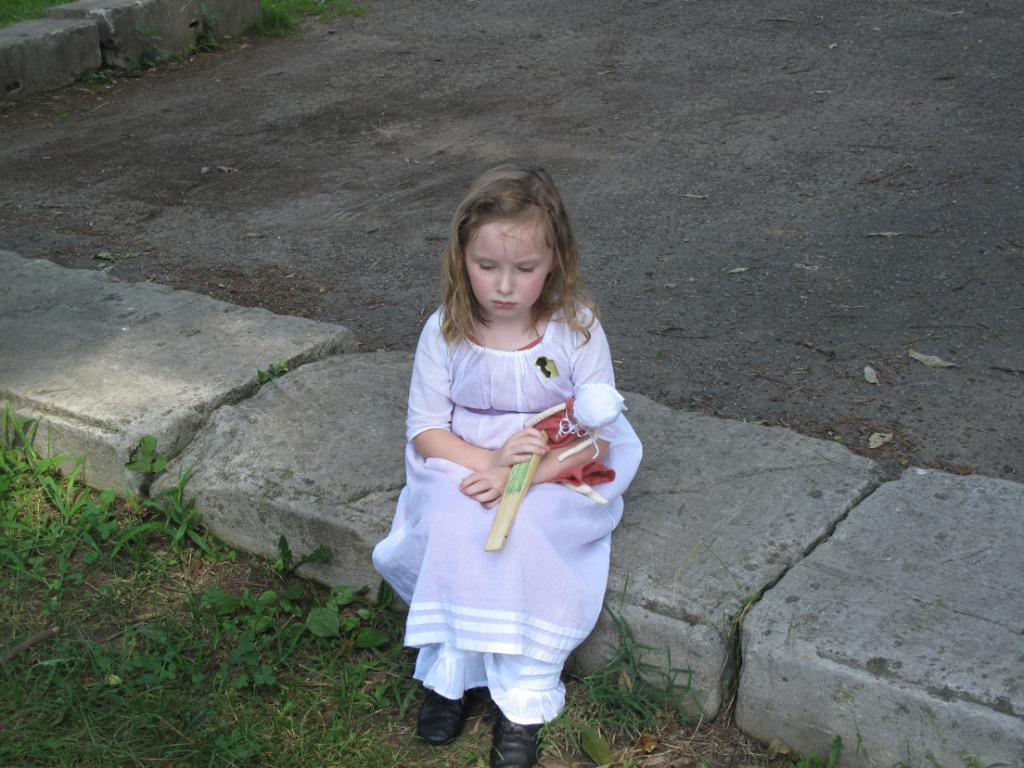Who is the main subject in the image? There is a girl in the image. What is the girl doing in the image? The girl is sitting on a stone. What is the girl holding in the image? The girl is holding a toy. What type of natural environment is visible at the bottom of the image? There is grass and plants at the bottom of the image. What can be seen in the background of the image? There is a road in the background of the image. What type of plantation can be seen in the image? There is no plantation present in the image; it features a girl sitting on a stone, holding a toy, with grass and plants at the bottom and a road in the background. What team is the girl playing for in the image? There is no team or sports activity depicted in the image. 